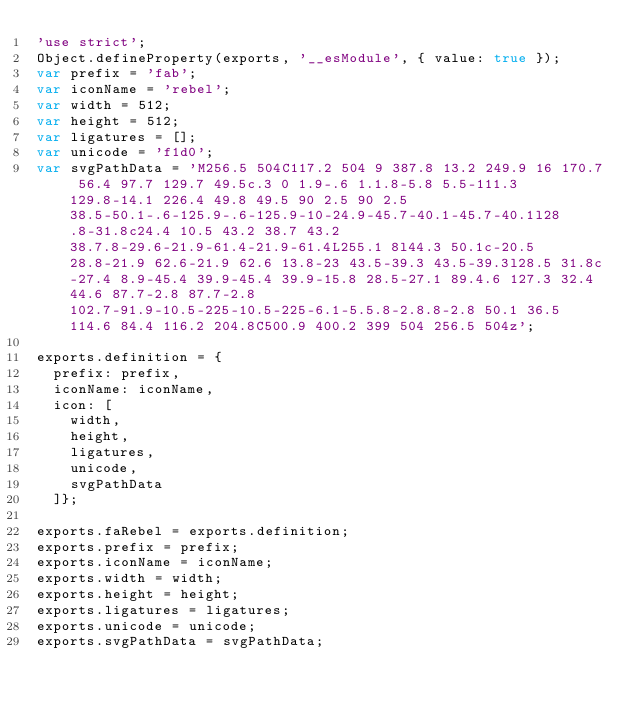Convert code to text. <code><loc_0><loc_0><loc_500><loc_500><_JavaScript_>'use strict';
Object.defineProperty(exports, '__esModule', { value: true });
var prefix = 'fab';
var iconName = 'rebel';
var width = 512;
var height = 512;
var ligatures = [];
var unicode = 'f1d0';
var svgPathData = 'M256.5 504C117.2 504 9 387.8 13.2 249.9 16 170.7 56.4 97.7 129.7 49.5c.3 0 1.9-.6 1.1.8-5.8 5.5-111.3 129.8-14.1 226.4 49.8 49.5 90 2.5 90 2.5 38.5-50.1-.6-125.9-.6-125.9-10-24.9-45.7-40.1-45.7-40.1l28.8-31.8c24.4 10.5 43.2 38.7 43.2 38.7.8-29.6-21.9-61.4-21.9-61.4L255.1 8l44.3 50.1c-20.5 28.8-21.9 62.6-21.9 62.6 13.8-23 43.5-39.3 43.5-39.3l28.5 31.8c-27.4 8.9-45.4 39.9-45.4 39.9-15.8 28.5-27.1 89.4.6 127.3 32.4 44.6 87.7-2.8 87.7-2.8 102.7-91.9-10.5-225-10.5-225-6.1-5.5.8-2.8.8-2.8 50.1 36.5 114.6 84.4 116.2 204.8C500.9 400.2 399 504 256.5 504z';

exports.definition = {           
  prefix: prefix,
  iconName: iconName,
  icon: [
    width,
    height,
    ligatures,
    unicode,
    svgPathData
  ]};
  
exports.faRebel = exports.definition;           
exports.prefix = prefix;
exports.iconName = iconName; 
exports.width = width;
exports.height = height;
exports.ligatures = ligatures;
exports.unicode = unicode;
exports.svgPathData = svgPathData;</code> 